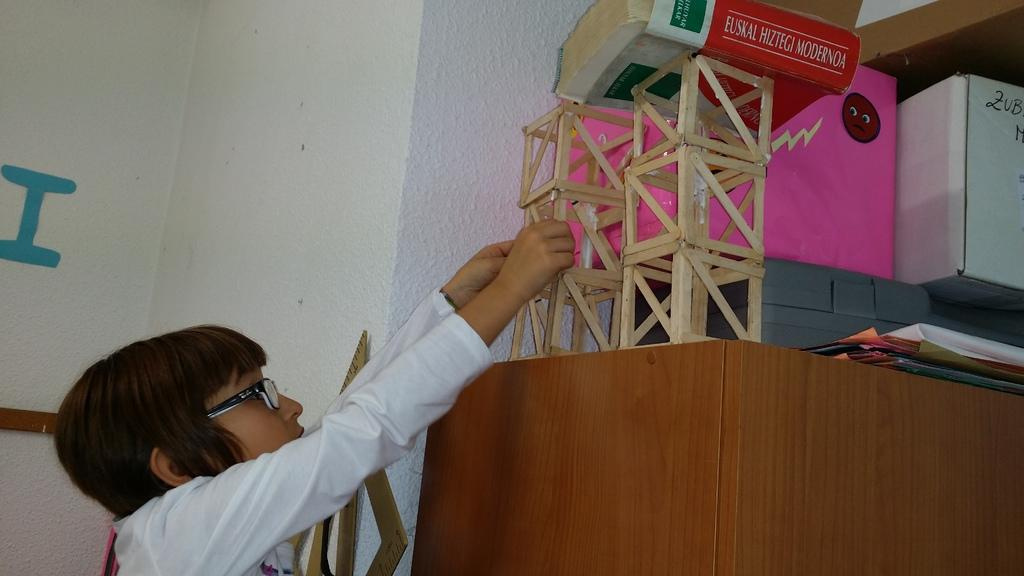Who or what is present in the image? There is a person in the image. What is the person holding or interacting with? The person is holding a book and there are papers in the image. Can you describe any other objects in the image? Yes, there are other objects in the image. What can be seen in the background of the image? There is a wall in the background of the image. What type of cloth is draped over the store in the image? There is no store or cloth present in the image. What advice is the coach giving to the person in the image? There is no coach or advice-giving situation depicted in the image. 